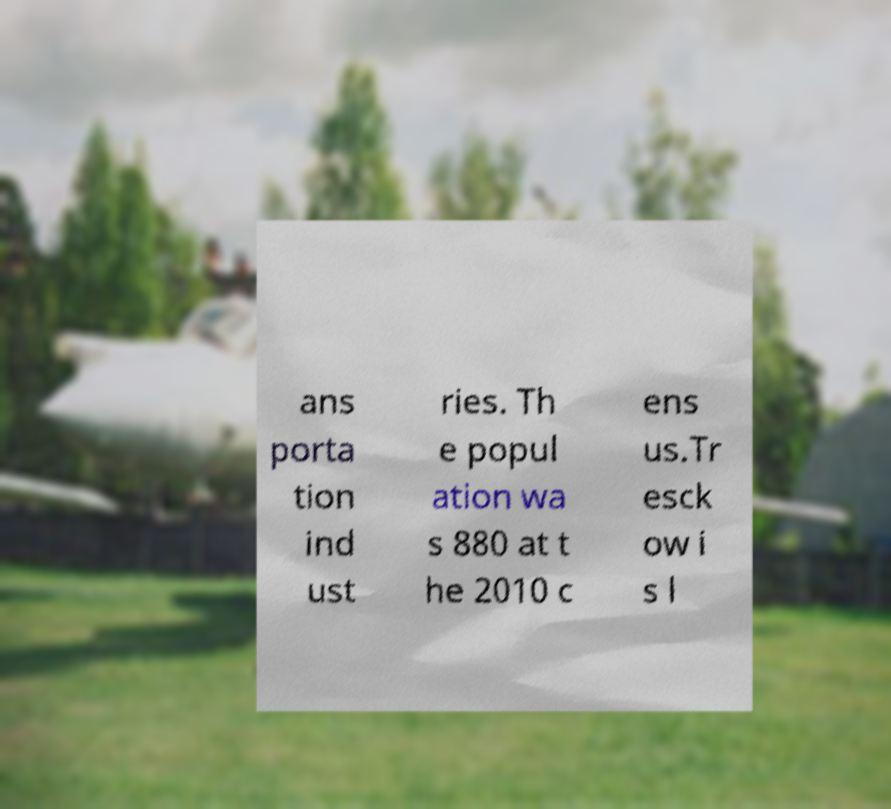For documentation purposes, I need the text within this image transcribed. Could you provide that? ans porta tion ind ust ries. Th e popul ation wa s 880 at t he 2010 c ens us.Tr esck ow i s l 